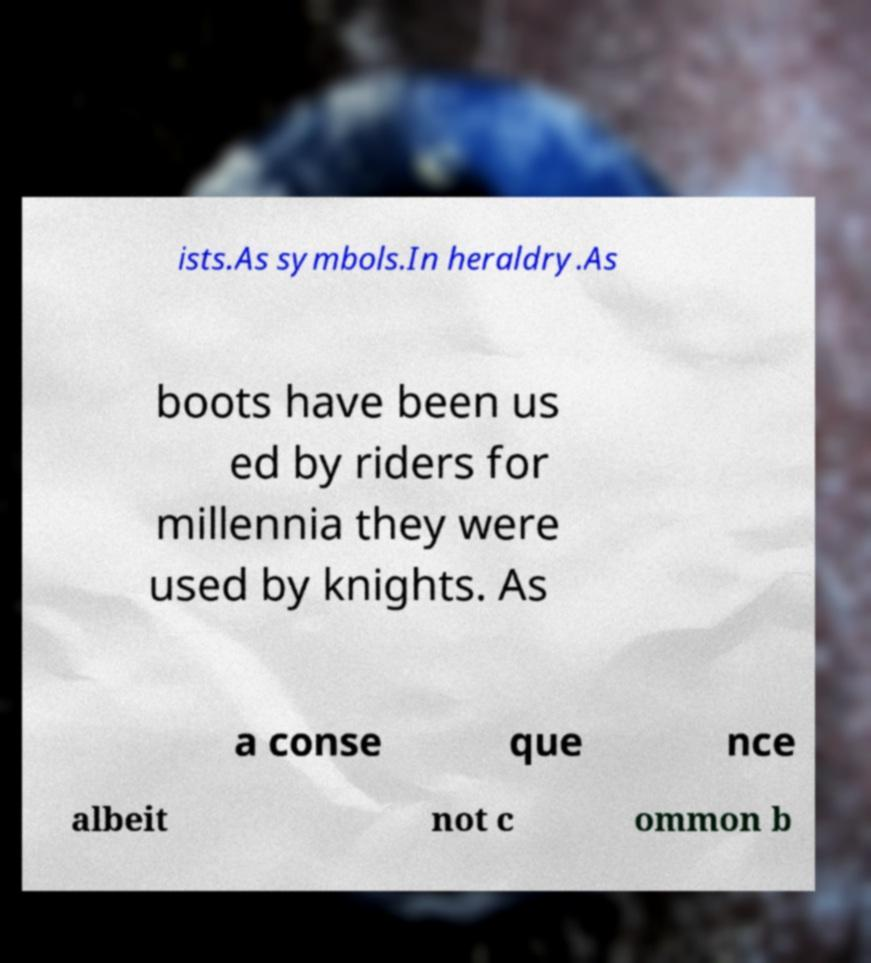Can you accurately transcribe the text from the provided image for me? ists.As symbols.In heraldry.As boots have been us ed by riders for millennia they were used by knights. As a conse que nce albeit not c ommon b 